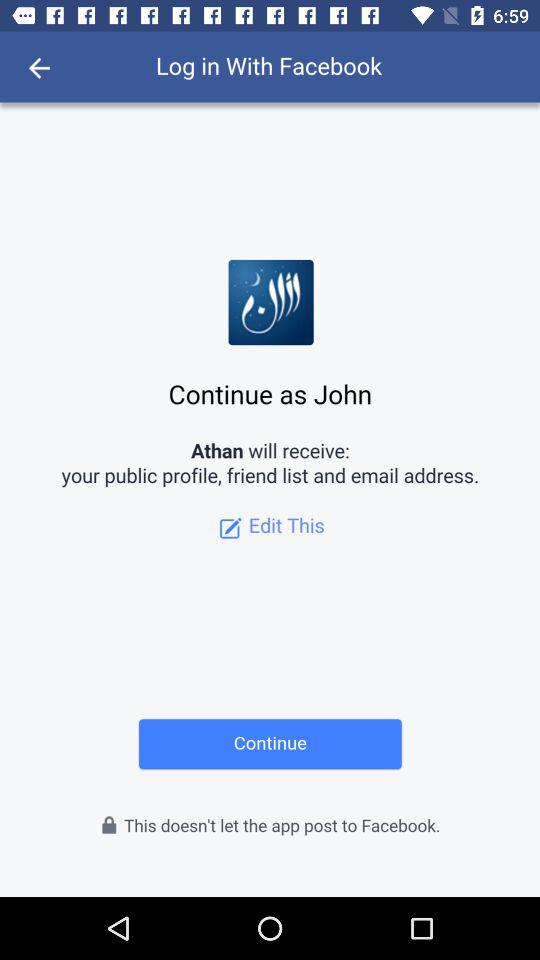Through what application are we logging in? You are logging in through "Facebook". 